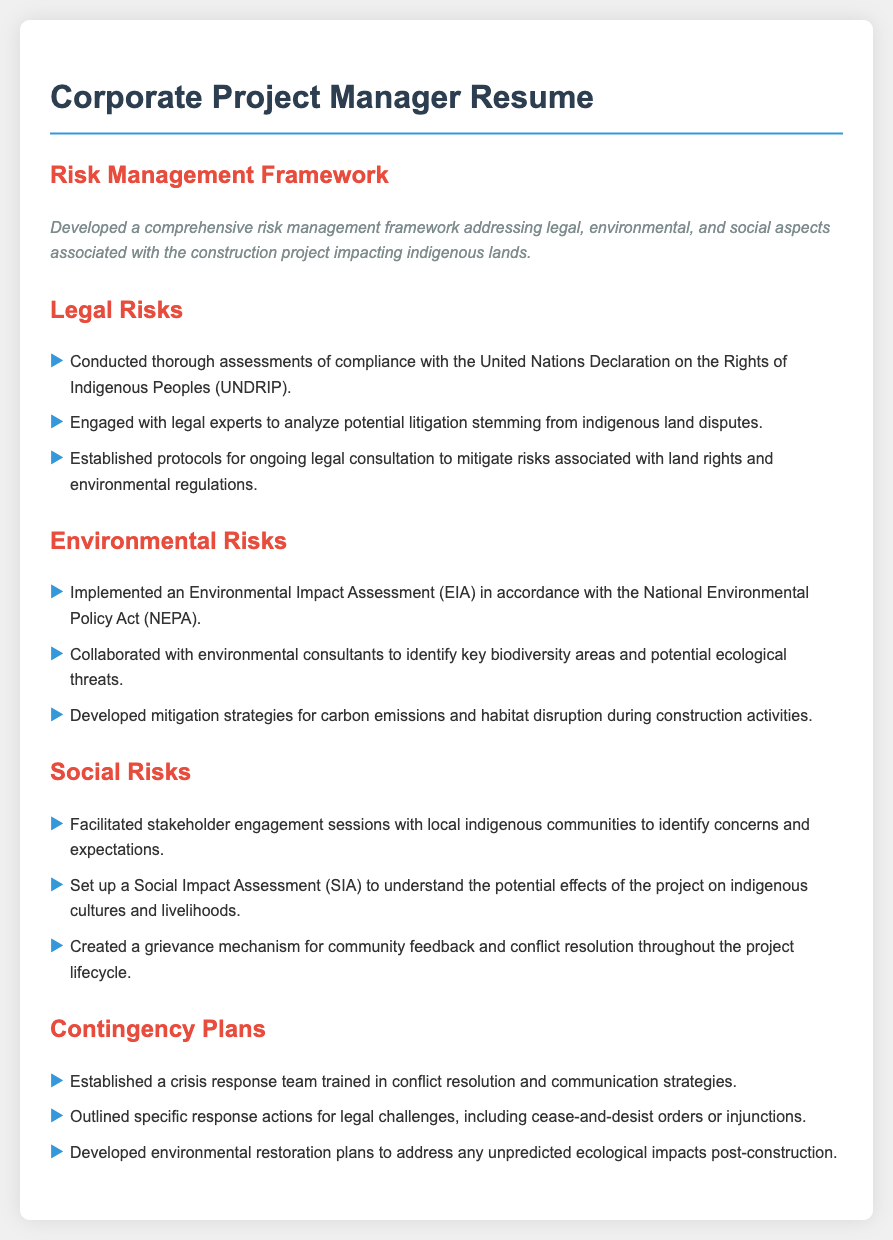what framework was developed? The framework developed addresses legal, environmental, and social aspects associated with the construction project.
Answer: risk management framework which declaration was assessed for compliance? The compliance assessment related to the rights of indigenous peoples mentioned in the document.
Answer: United Nations Declaration on the Rights of Indigenous Peoples who was engaged to analyze potential litigation? The individuals or groups involved in analyzing litigation regarding land disputes are not specified in detail but refer to professional experts.
Answer: legal experts what type of assessment was implemented for environmental risks? The assessment performed to understand environmental implications is a standard procedure mandated by national regulations.
Answer: Environmental Impact Assessment what mechanism was created for community feedback? The document mentions a system established to ensure that the voice of the community is heard during the project lifecycle.
Answer: grievance mechanism what team was established for crisis response? The response team formed to handle crises is specified for training in certain skills essential for conflict scenarios.
Answer: crisis response team which assessments were facilitated with local communities? The assessments conducted to connect with the indigenous communities were aimed at gathering insights on their perspectives.
Answer: Social Impact Assessment what plans were developed for unforeseen ecological impacts? The plans outlined in the document focus on restoring the environment in response to unexpected ecological changes during the project.
Answer: environmental restoration plans 